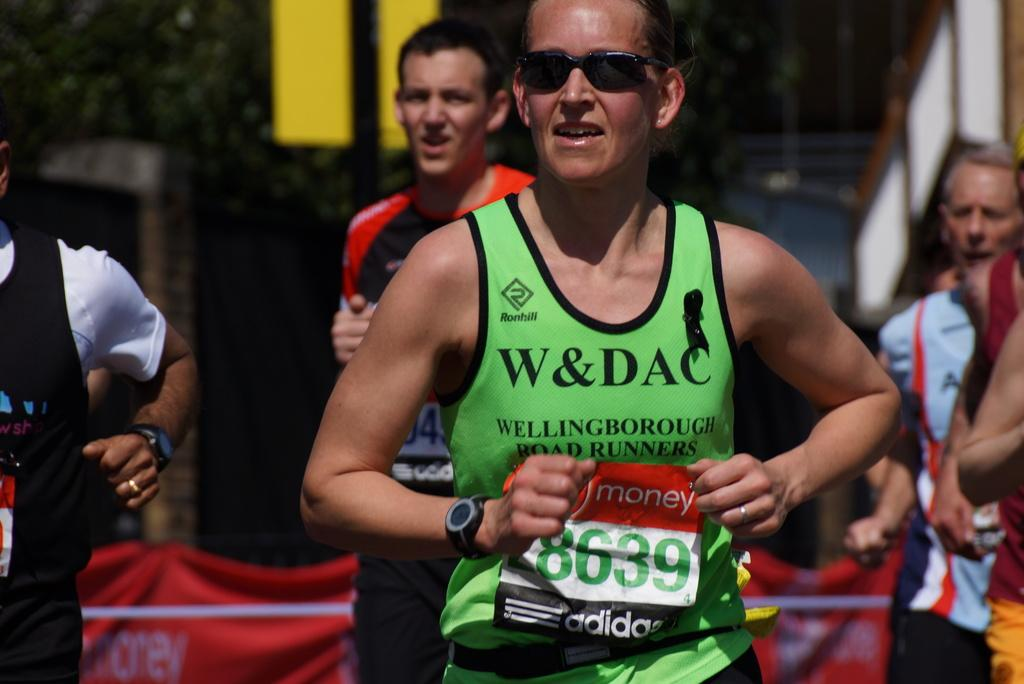<image>
Render a clear and concise summary of the photo. A girl runs with a Wellingborough tank top. 